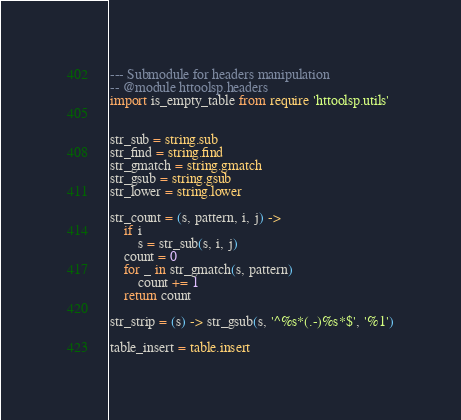Convert code to text. <code><loc_0><loc_0><loc_500><loc_500><_MoonScript_>--- Submodule for headers manipulation
-- @module httoolsp.headers
import is_empty_table from require 'httoolsp.utils'


str_sub = string.sub
str_find = string.find
str_gmatch = string.gmatch
str_gsub = string.gsub
str_lower = string.lower

str_count = (s, pattern, i, j) ->
    if i
        s = str_sub(s, i, j)
    count = 0
    for _ in str_gmatch(s, pattern)
        count += 1
    return count

str_strip = (s) -> str_gsub(s, '^%s*(.-)%s*$', '%1')

table_insert = table.insert</code> 